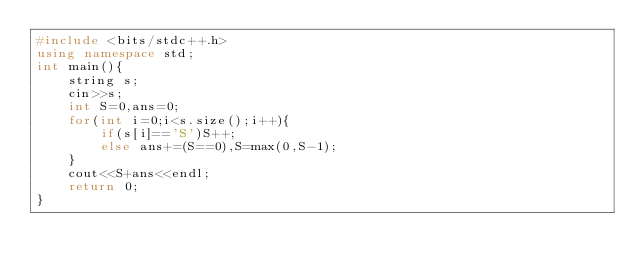<code> <loc_0><loc_0><loc_500><loc_500><_C++_>#include <bits/stdc++.h>
using namespace std;
int main(){
	string s;
	cin>>s;
	int S=0,ans=0;
	for(int i=0;i<s.size();i++){
		if(s[i]=='S')S++;
		else ans+=(S==0),S=max(0,S-1);
	}
	cout<<S+ans<<endl;	
	return 0;
}
</code> 